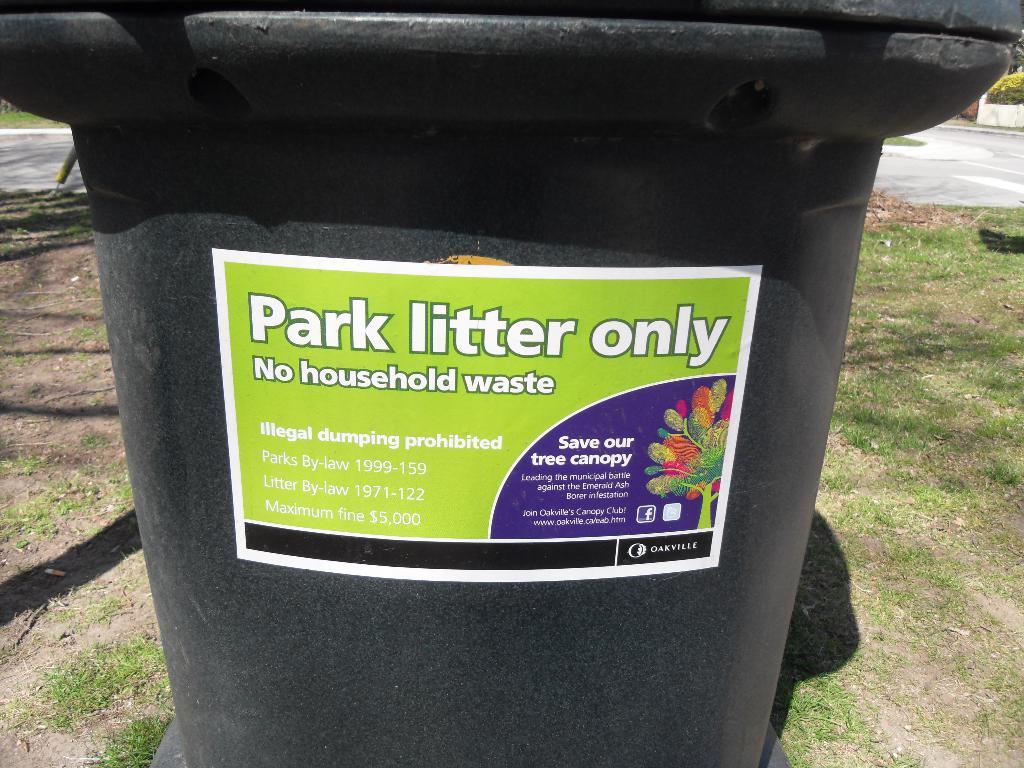Why can't we throw household waste in it?
Ensure brevity in your answer.  Park litter only. What colour is the bin?
Make the answer very short. Black. 